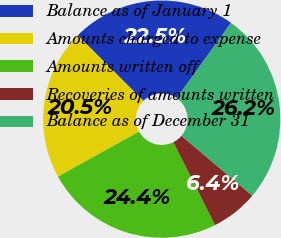<chart> <loc_0><loc_0><loc_500><loc_500><pie_chart><fcel>Balance as of January 1<fcel>Amounts charged to expense<fcel>Amounts written off<fcel>Recoveries of amounts written<fcel>Balance as of December 31<nl><fcel>22.45%<fcel>20.53%<fcel>24.37%<fcel>6.41%<fcel>26.23%<nl></chart> 